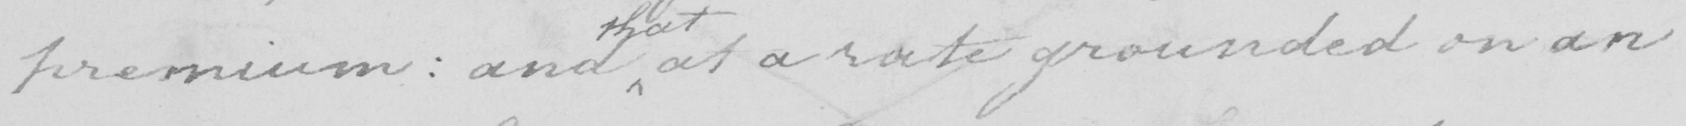What does this handwritten line say? premium  :  and at a rate grounded on an 